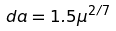Convert formula to latex. <formula><loc_0><loc_0><loc_500><loc_500>d a = 1 . 5 \mu ^ { 2 / 7 }</formula> 